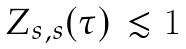Convert formula to latex. <formula><loc_0><loc_0><loc_500><loc_500>\begin{array} { l l } Z _ { s , s } ( \tau ) & \lesssim 1 \end{array}</formula> 